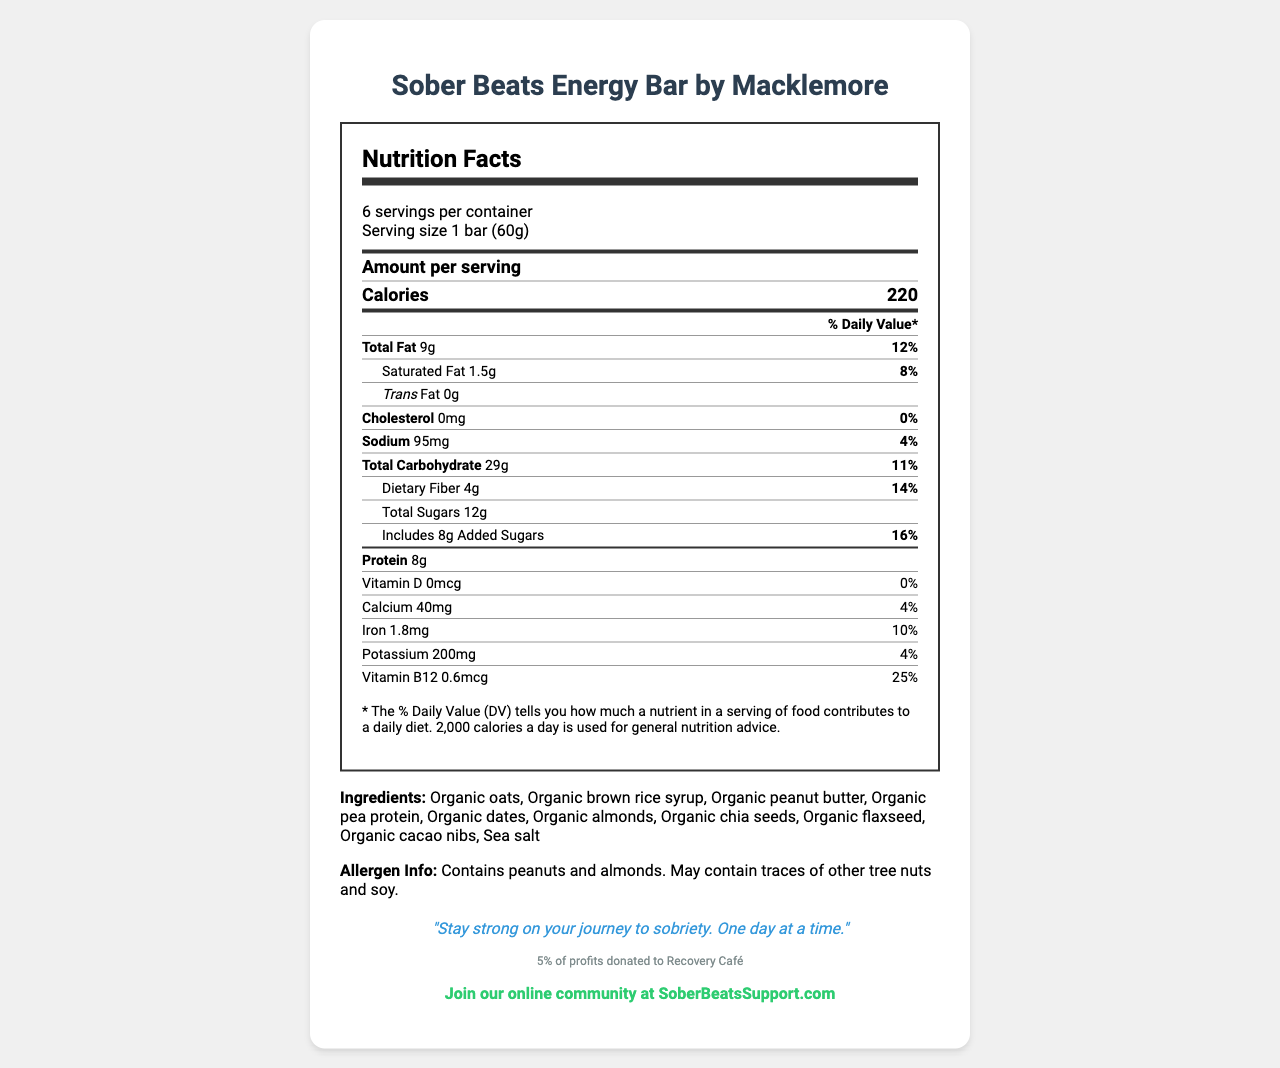what is the product name? The product name is clearly stated at the very top of the document: "Sober Beats Energy Bar".
Answer: Sober Beats Energy Bar who collaborated with the musician to create this product? The musician collaborator is stated right next to the product name: "by Macklemore".
Answer: Macklemore how many servings are there per container? The servings per container information is provided under the servings section: "6 servings per container".
Answer: 6 what is the total fat content per serving? The total fat content per serving is listed under the nutrition facts: "Total Fat 9g".
Answer: 9g how much protein does one bar contain? The protein content per serving is stated in the nutrition facts: "Protein 8g".
Answer: 8g how much of the daily value percentage is the saturated fat per serving? The % Daily Value for saturated fat is listed in the nutrition facts: "Saturated Fat 1.5g 8%".
Answer: 8% how much calcium is in one serving? The calcium content per serving is provided in the nutrition facts: "Calcium 40mg".
Answer: 40mg which nutrient has the highest daily value percentage? A. Iron B. Vitamin B12 C. Protein D. Sodium Vitamin B12 has the highest % Daily Value at 25%.
Answer: B what is the daily value percentage for iron? A. 4% B. 10% C. 14% D. 8% The % Daily Value for iron is given in the nutrition facts: "Iron 1.8mg 10%".
Answer: B does this product contain any cholesterol? The cholesterol content per serving is listed as "0mg", which is accompanied by a 0% Daily Value, indicating there is no cholesterol.
Answer: No does this product contain any dairy ingredients? The ingredients do not explicitly mention dairy, and there is no clear allergen information specifically about dairy. Therefore, it cannot be determined.
Answer: Cannot be determined what is the main message from Macklemore related to this product? The recovery message from Macklemore is highlighted in the document: "Stay strong on your journey to sobriety. One day at a time."
Answer: Stay strong on your journey to sobriety. One day at a time. what charity benefits from the sales of this product? The document states: "5% of profits donated to Recovery Café".
Answer: Recovery Café summarize the main purpose of this document. This document provides comprehensive information about the Sober Beats Energy Bar, emphasizing its nutritional benefits, the recovery message, and the social cause it supports.
Answer: The document describes the Sober Beats Energy Bar, a collaboration between the musician Macklemore and a manufacturer, aimed at promoting healthy snacking while supporting sobriety. It includes detailed nutrition facts, ingredients, allergen information, a recovery message, the charity donation details, and support group information. 